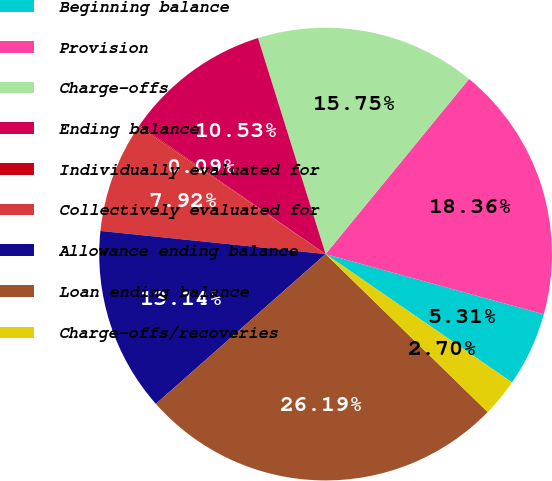<chart> <loc_0><loc_0><loc_500><loc_500><pie_chart><fcel>Beginning balance<fcel>Provision<fcel>Charge-offs<fcel>Ending balance<fcel>Individually evaluated for<fcel>Collectively evaluated for<fcel>Allowance ending balance<fcel>Loan ending balance<fcel>Charge-offs/recoveries<nl><fcel>5.31%<fcel>18.36%<fcel>15.75%<fcel>10.53%<fcel>0.09%<fcel>7.92%<fcel>13.14%<fcel>26.19%<fcel>2.7%<nl></chart> 